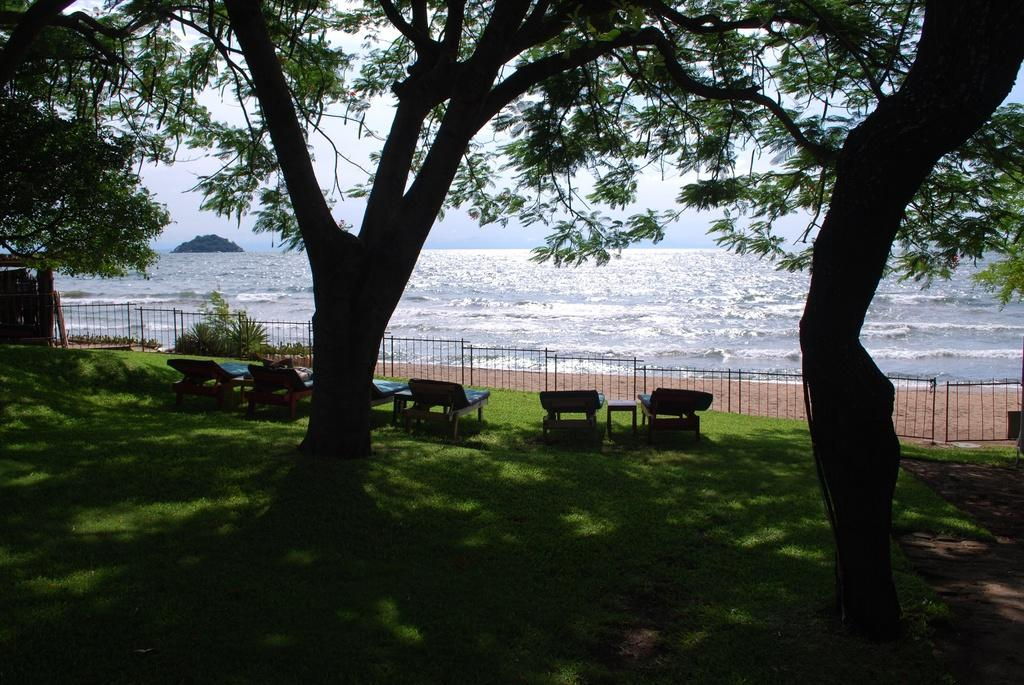What type of vegetation can be seen in the image? There are trees in the image. What type of furniture is present in the image? There are chairs and tables in the image. What type of architectural feature can be seen in the image? There are iron grilles or barriers in the image. What type of ground surface is visible in the image? There is grass in the image. What type of natural feature can be seen in the image? There is water and a hill in the image. What is visible in the background of the image? The sky is visible in the background of the image. How many rabbits are sitting on the chairs in the image? There are no rabbits present in the image. What type of lipstick is being used on the table in the image? There is no lipstick or any cosmetic product visible in the image. 